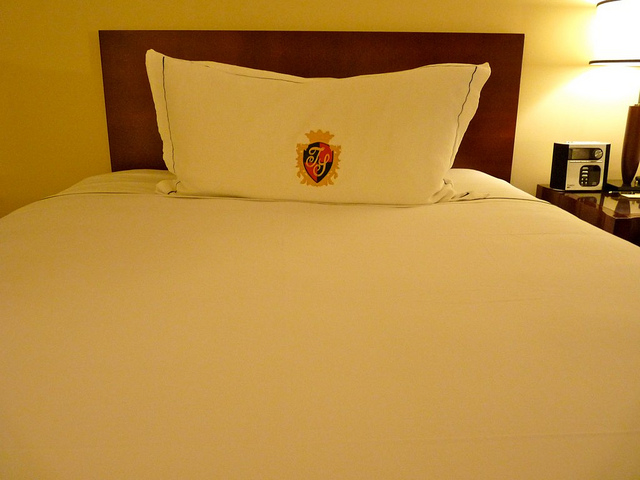Please transcribe the text information in this image. J S 